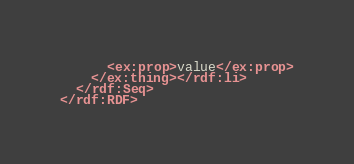<code> <loc_0><loc_0><loc_500><loc_500><_XML_>      <ex:prop>value</ex:prop>
    </ex:thing></rdf:li>
  </rdf:Seq>
</rdf:RDF>
</code> 